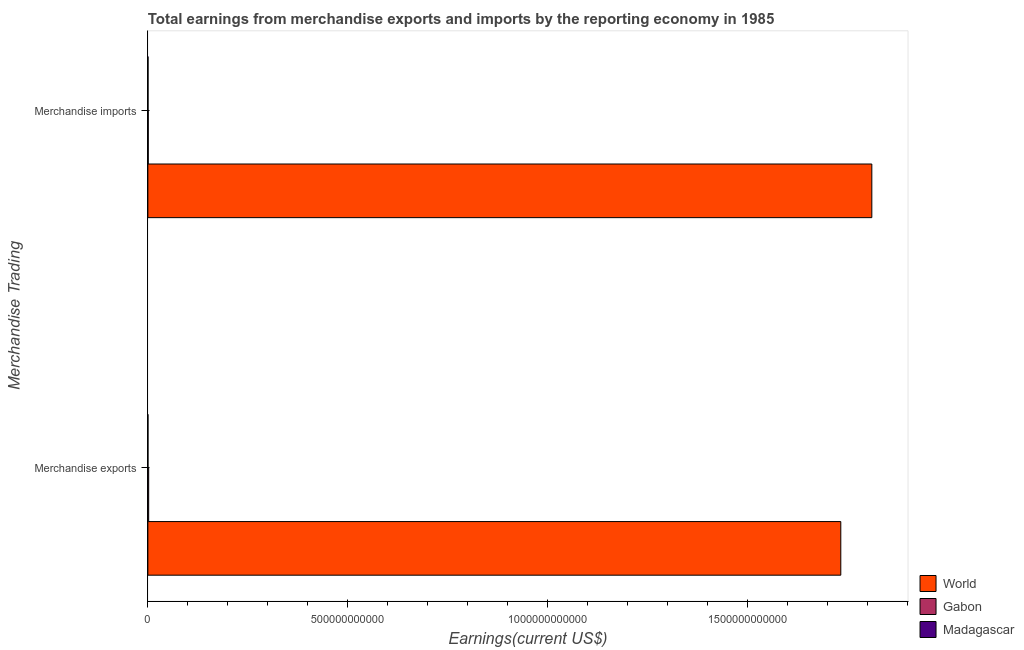How many different coloured bars are there?
Your response must be concise. 3. How many groups of bars are there?
Give a very brief answer. 2. Are the number of bars per tick equal to the number of legend labels?
Give a very brief answer. Yes. Are the number of bars on each tick of the Y-axis equal?
Make the answer very short. Yes. How many bars are there on the 1st tick from the bottom?
Keep it short and to the point. 3. What is the label of the 2nd group of bars from the top?
Offer a very short reply. Merchandise exports. What is the earnings from merchandise imports in Gabon?
Make the answer very short. 9.57e+08. Across all countries, what is the maximum earnings from merchandise imports?
Offer a very short reply. 1.81e+12. Across all countries, what is the minimum earnings from merchandise imports?
Your answer should be very brief. 4.00e+08. In which country was the earnings from merchandise exports minimum?
Your response must be concise. Madagascar. What is the total earnings from merchandise imports in the graph?
Provide a succinct answer. 1.81e+12. What is the difference between the earnings from merchandise imports in Gabon and that in Madagascar?
Provide a short and direct response. 5.57e+08. What is the difference between the earnings from merchandise imports in World and the earnings from merchandise exports in Madagascar?
Give a very brief answer. 1.81e+12. What is the average earnings from merchandise imports per country?
Ensure brevity in your answer.  6.04e+11. What is the difference between the earnings from merchandise exports and earnings from merchandise imports in World?
Provide a short and direct response. -7.76e+1. What is the ratio of the earnings from merchandise exports in World to that in Madagascar?
Offer a terse response. 6527.2. Is the earnings from merchandise imports in World less than that in Gabon?
Offer a very short reply. No. What does the 2nd bar from the top in Merchandise imports represents?
Offer a very short reply. Gabon. What does the 2nd bar from the bottom in Merchandise imports represents?
Provide a short and direct response. Gabon. Are all the bars in the graph horizontal?
Your answer should be very brief. Yes. How many countries are there in the graph?
Offer a very short reply. 3. What is the difference between two consecutive major ticks on the X-axis?
Your response must be concise. 5.00e+11. Are the values on the major ticks of X-axis written in scientific E-notation?
Your answer should be very brief. No. Does the graph contain any zero values?
Give a very brief answer. No. Does the graph contain grids?
Make the answer very short. No. How are the legend labels stacked?
Ensure brevity in your answer.  Vertical. What is the title of the graph?
Ensure brevity in your answer.  Total earnings from merchandise exports and imports by the reporting economy in 1985. What is the label or title of the X-axis?
Your answer should be very brief. Earnings(current US$). What is the label or title of the Y-axis?
Your response must be concise. Merchandise Trading. What is the Earnings(current US$) in World in Merchandise exports?
Your answer should be compact. 1.73e+12. What is the Earnings(current US$) of Gabon in Merchandise exports?
Provide a short and direct response. 2.00e+09. What is the Earnings(current US$) of Madagascar in Merchandise exports?
Your answer should be very brief. 2.65e+08. What is the Earnings(current US$) of World in Merchandise imports?
Ensure brevity in your answer.  1.81e+12. What is the Earnings(current US$) of Gabon in Merchandise imports?
Offer a terse response. 9.57e+08. What is the Earnings(current US$) in Madagascar in Merchandise imports?
Offer a terse response. 4.00e+08. Across all Merchandise Trading, what is the maximum Earnings(current US$) of World?
Offer a very short reply. 1.81e+12. Across all Merchandise Trading, what is the maximum Earnings(current US$) of Gabon?
Keep it short and to the point. 2.00e+09. Across all Merchandise Trading, what is the maximum Earnings(current US$) of Madagascar?
Offer a terse response. 4.00e+08. Across all Merchandise Trading, what is the minimum Earnings(current US$) of World?
Your answer should be compact. 1.73e+12. Across all Merchandise Trading, what is the minimum Earnings(current US$) of Gabon?
Ensure brevity in your answer.  9.57e+08. Across all Merchandise Trading, what is the minimum Earnings(current US$) of Madagascar?
Offer a terse response. 2.65e+08. What is the total Earnings(current US$) in World in the graph?
Provide a succinct answer. 3.54e+12. What is the total Earnings(current US$) of Gabon in the graph?
Keep it short and to the point. 2.96e+09. What is the total Earnings(current US$) in Madagascar in the graph?
Make the answer very short. 6.66e+08. What is the difference between the Earnings(current US$) of World in Merchandise exports and that in Merchandise imports?
Provide a succinct answer. -7.76e+1. What is the difference between the Earnings(current US$) of Gabon in Merchandise exports and that in Merchandise imports?
Make the answer very short. 1.04e+09. What is the difference between the Earnings(current US$) of Madagascar in Merchandise exports and that in Merchandise imports?
Keep it short and to the point. -1.35e+08. What is the difference between the Earnings(current US$) of World in Merchandise exports and the Earnings(current US$) of Gabon in Merchandise imports?
Your answer should be very brief. 1.73e+12. What is the difference between the Earnings(current US$) of World in Merchandise exports and the Earnings(current US$) of Madagascar in Merchandise imports?
Your response must be concise. 1.73e+12. What is the difference between the Earnings(current US$) in Gabon in Merchandise exports and the Earnings(current US$) in Madagascar in Merchandise imports?
Provide a succinct answer. 1.60e+09. What is the average Earnings(current US$) of World per Merchandise Trading?
Make the answer very short. 1.77e+12. What is the average Earnings(current US$) in Gabon per Merchandise Trading?
Offer a very short reply. 1.48e+09. What is the average Earnings(current US$) in Madagascar per Merchandise Trading?
Provide a succinct answer. 3.33e+08. What is the difference between the Earnings(current US$) in World and Earnings(current US$) in Gabon in Merchandise exports?
Offer a terse response. 1.73e+12. What is the difference between the Earnings(current US$) of World and Earnings(current US$) of Madagascar in Merchandise exports?
Offer a very short reply. 1.73e+12. What is the difference between the Earnings(current US$) in Gabon and Earnings(current US$) in Madagascar in Merchandise exports?
Provide a short and direct response. 1.73e+09. What is the difference between the Earnings(current US$) of World and Earnings(current US$) of Gabon in Merchandise imports?
Offer a terse response. 1.81e+12. What is the difference between the Earnings(current US$) of World and Earnings(current US$) of Madagascar in Merchandise imports?
Keep it short and to the point. 1.81e+12. What is the difference between the Earnings(current US$) of Gabon and Earnings(current US$) of Madagascar in Merchandise imports?
Offer a very short reply. 5.57e+08. What is the ratio of the Earnings(current US$) in World in Merchandise exports to that in Merchandise imports?
Your response must be concise. 0.96. What is the ratio of the Earnings(current US$) of Gabon in Merchandise exports to that in Merchandise imports?
Your answer should be very brief. 2.09. What is the ratio of the Earnings(current US$) of Madagascar in Merchandise exports to that in Merchandise imports?
Offer a terse response. 0.66. What is the difference between the highest and the second highest Earnings(current US$) of World?
Your response must be concise. 7.76e+1. What is the difference between the highest and the second highest Earnings(current US$) in Gabon?
Provide a short and direct response. 1.04e+09. What is the difference between the highest and the second highest Earnings(current US$) in Madagascar?
Provide a short and direct response. 1.35e+08. What is the difference between the highest and the lowest Earnings(current US$) in World?
Offer a terse response. 7.76e+1. What is the difference between the highest and the lowest Earnings(current US$) of Gabon?
Keep it short and to the point. 1.04e+09. What is the difference between the highest and the lowest Earnings(current US$) in Madagascar?
Ensure brevity in your answer.  1.35e+08. 